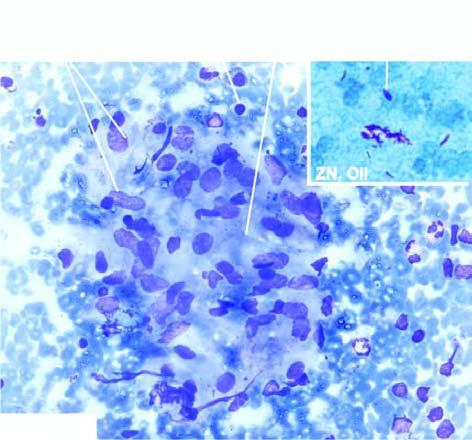does inbox show ziehl-neelsen staining having many tubercle bacilli?
Answer the question using a single word or phrase. Yes 